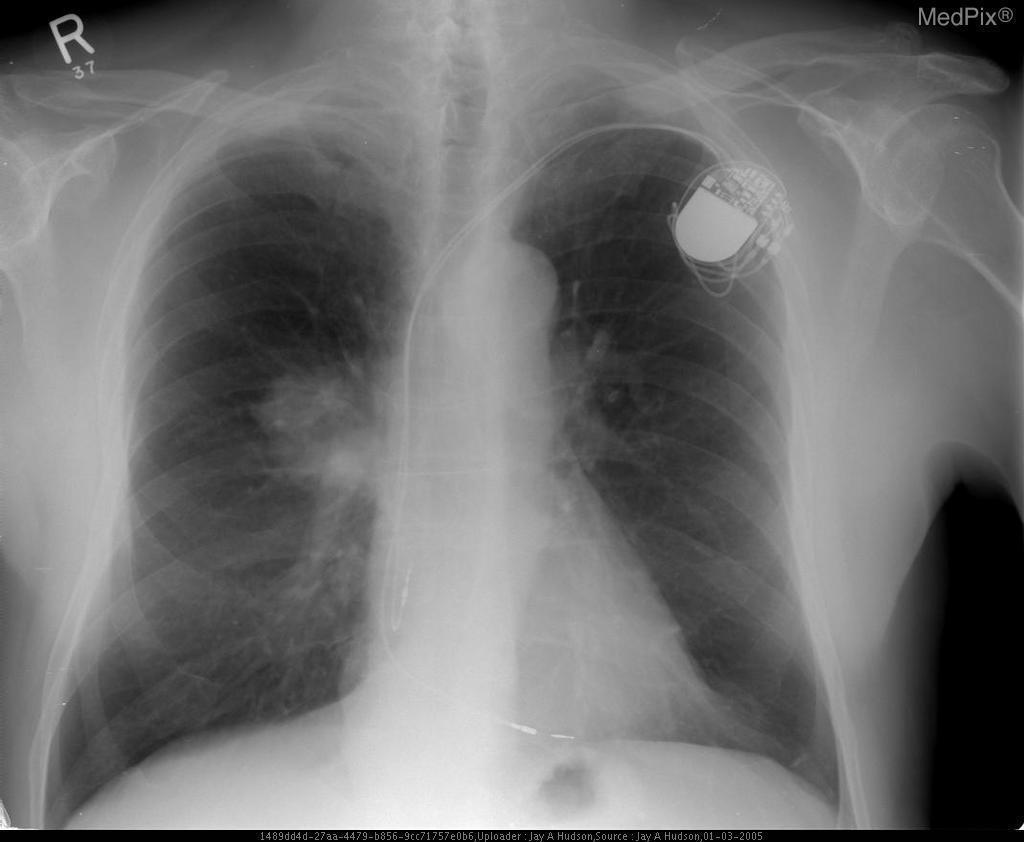Are the ribs broken?
Keep it brief. No. Is the air under the left hemidiaphragm pathologic?
Keep it brief. No. Is there free air under the left diaphragm?
Write a very short answer. No. Is the opacity near the left lung apex pathologic?
Keep it brief. No. What is the opacity near the left lung apex?
Concise answer only. Pacemaker. Where is the lesion?
Answer briefly. In the right hilum. Which lobe is the lesion located in?
Answer briefly. Upper right lobe. 